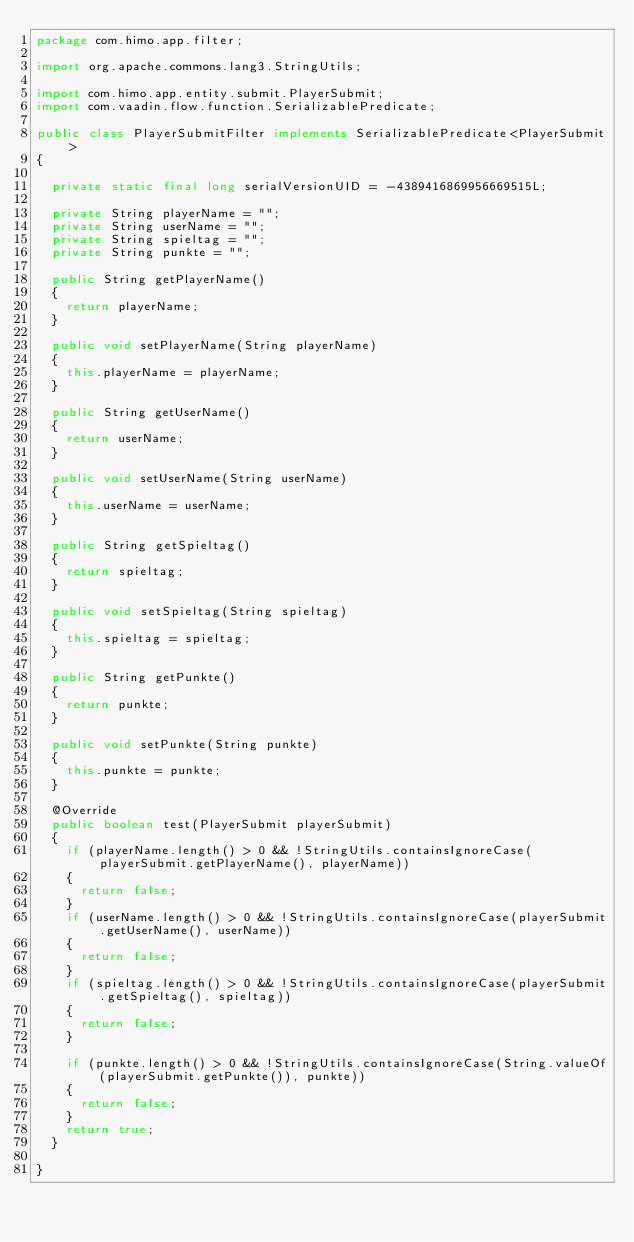Convert code to text. <code><loc_0><loc_0><loc_500><loc_500><_Java_>package com.himo.app.filter;

import org.apache.commons.lang3.StringUtils;

import com.himo.app.entity.submit.PlayerSubmit;
import com.vaadin.flow.function.SerializablePredicate;

public class PlayerSubmitFilter implements SerializablePredicate<PlayerSubmit>
{

	private static final long serialVersionUID = -4389416869956669515L;

	private String playerName = "";
	private String userName = "";
	private String spieltag = "";
	private String punkte = "";

	public String getPlayerName()
	{
		return playerName;
	}

	public void setPlayerName(String playerName)
	{
		this.playerName = playerName;
	}

	public String getUserName()
	{
		return userName;
	}

	public void setUserName(String userName)
	{
		this.userName = userName;
	}

	public String getSpieltag()
	{
		return spieltag;
	}

	public void setSpieltag(String spieltag)
	{
		this.spieltag = spieltag;
	}

	public String getPunkte()
	{
		return punkte;
	}

	public void setPunkte(String punkte)
	{
		this.punkte = punkte;
	}

	@Override
	public boolean test(PlayerSubmit playerSubmit)
	{
		if (playerName.length() > 0 && !StringUtils.containsIgnoreCase(playerSubmit.getPlayerName(), playerName))
		{
			return false;
		}
		if (userName.length() > 0 && !StringUtils.containsIgnoreCase(playerSubmit.getUserName(), userName))
		{
			return false;
		}
		if (spieltag.length() > 0 && !StringUtils.containsIgnoreCase(playerSubmit.getSpieltag(), spieltag))
		{
			return false;
		}

		if (punkte.length() > 0 && !StringUtils.containsIgnoreCase(String.valueOf(playerSubmit.getPunkte()), punkte))
		{
			return false;
		}
		return true;
	}

}
</code> 